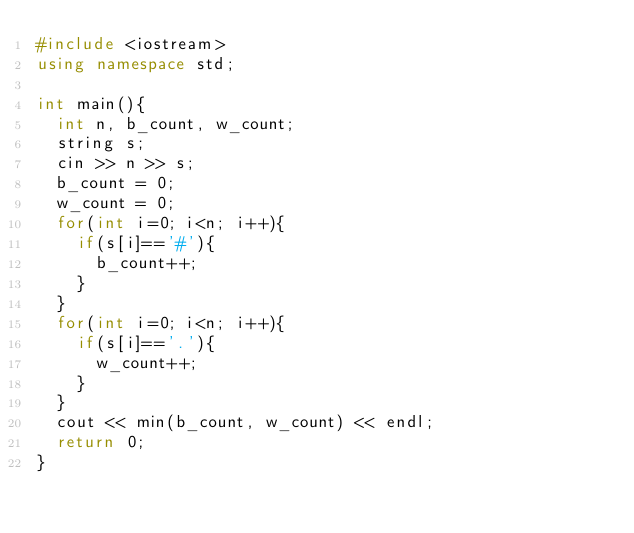<code> <loc_0><loc_0><loc_500><loc_500><_C++_>#include <iostream>
using namespace std;

int main(){
	int n, b_count, w_count;
	string s;
	cin >> n >> s;
	b_count = 0;
	w_count = 0;
	for(int i=0; i<n; i++){
		if(s[i]=='#'){
			b_count++;
		}
	}
	for(int i=0; i<n; i++){
		if(s[i]=='.'){
			w_count++;
		}
	}
	cout << min(b_count, w_count) << endl;
	return 0;
}</code> 